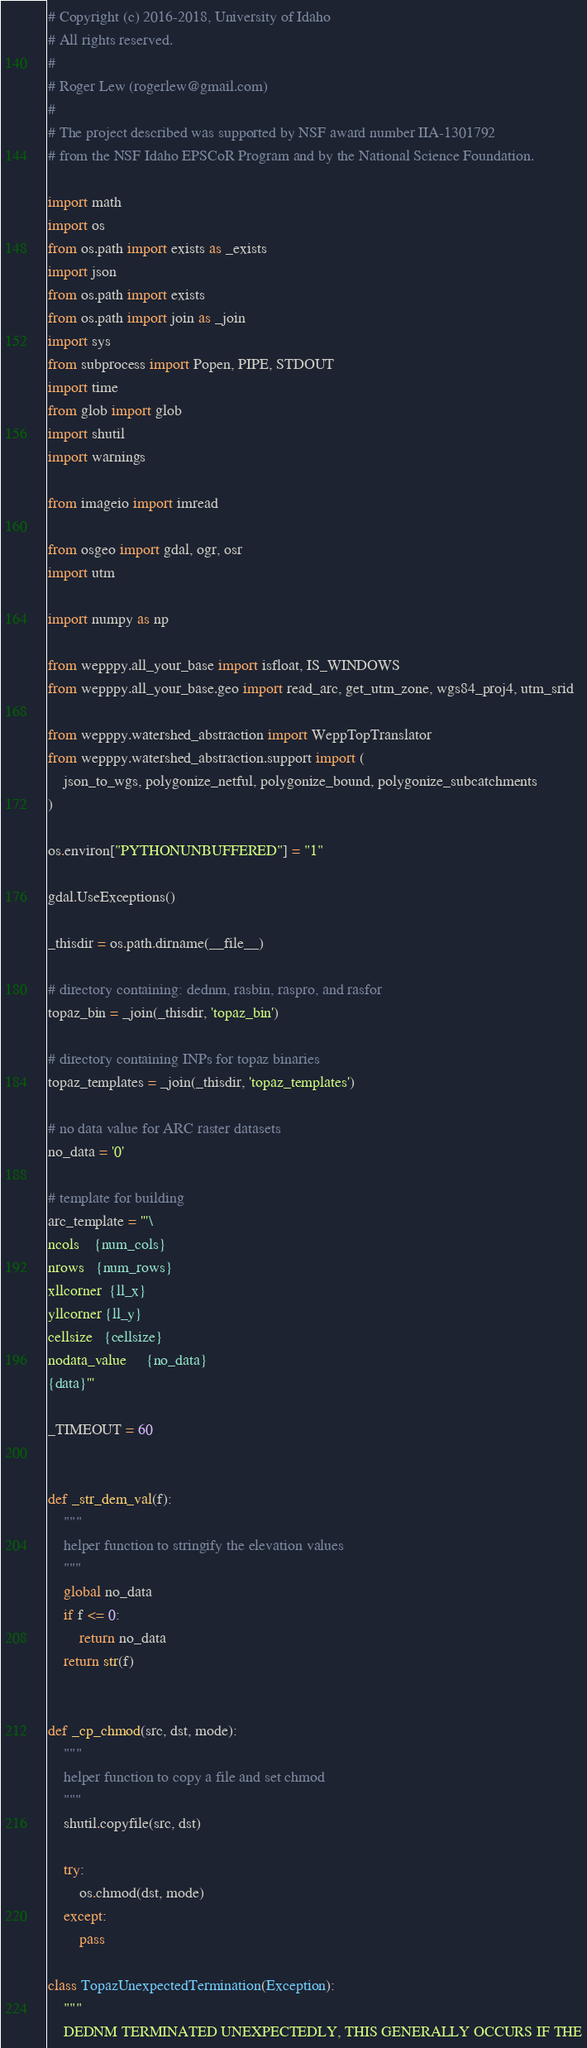Convert code to text. <code><loc_0><loc_0><loc_500><loc_500><_Python_># Copyright (c) 2016-2018, University of Idaho
# All rights reserved.
#
# Roger Lew (rogerlew@gmail.com)
#
# The project described was supported by NSF award number IIA-1301792
# from the NSF Idaho EPSCoR Program and by the National Science Foundation.

import math
import os
from os.path import exists as _exists
import json
from os.path import exists
from os.path import join as _join
import sys
from subprocess import Popen, PIPE, STDOUT
import time
from glob import glob
import shutil
import warnings

from imageio import imread

from osgeo import gdal, ogr, osr
import utm

import numpy as np

from wepppy.all_your_base import isfloat, IS_WINDOWS
from wepppy.all_your_base.geo import read_arc, get_utm_zone, wgs84_proj4, utm_srid

from wepppy.watershed_abstraction import WeppTopTranslator
from wepppy.watershed_abstraction.support import (
    json_to_wgs, polygonize_netful, polygonize_bound, polygonize_subcatchments
)

os.environ["PYTHONUNBUFFERED"] = "1"

gdal.UseExceptions()

_thisdir = os.path.dirname(__file__)

# directory containing: dednm, rasbin, raspro, and rasfor
topaz_bin = _join(_thisdir, 'topaz_bin')

# directory containing INPs for topaz binaries
topaz_templates = _join(_thisdir, 'topaz_templates')

# no data value for ARC raster datasets
no_data = '0'

# template for building
arc_template = '''\
ncols    {num_cols}
nrows   {num_rows}
xllcorner  {ll_x}
yllcorner {ll_y}
cellsize   {cellsize}
nodata_value     {no_data}
{data}'''

_TIMEOUT = 60


def _str_dem_val(f):
    """
    helper function to stringify the elevation values
    """
    global no_data
    if f <= 0:
        return no_data
    return str(f)


def _cp_chmod(src, dst, mode):
    """
    helper function to copy a file and set chmod
    """
    shutil.copyfile(src, dst)

    try:
        os.chmod(dst, mode)
    except:
        pass

class TopazUnexpectedTermination(Exception):
    """
    DEDNM TERMINATED UNEXPECTEDLY, THIS GENERALLY OCCURS IF THE</code> 